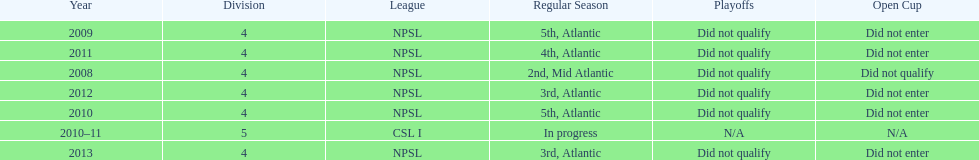How many 3rd place finishes has npsl had? 2. 